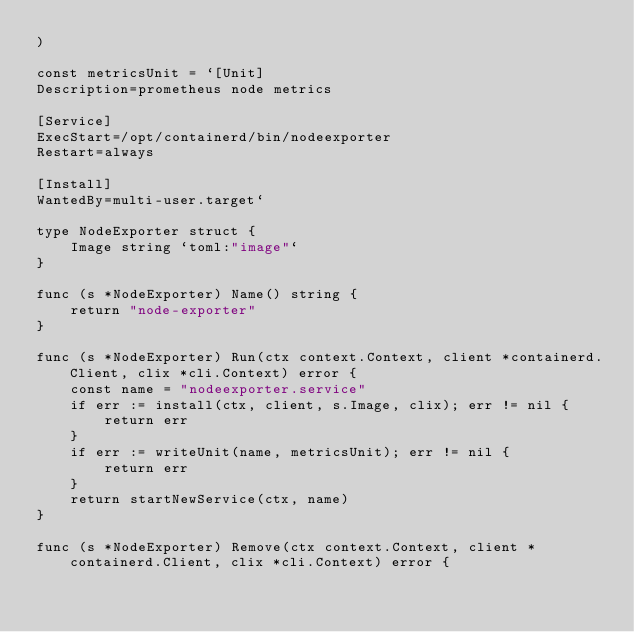Convert code to text. <code><loc_0><loc_0><loc_500><loc_500><_Go_>)

const metricsUnit = `[Unit]
Description=prometheus node metrics

[Service]
ExecStart=/opt/containerd/bin/nodeexporter
Restart=always

[Install]
WantedBy=multi-user.target`

type NodeExporter struct {
	Image string `toml:"image"`
}

func (s *NodeExporter) Name() string {
	return "node-exporter"
}

func (s *NodeExporter) Run(ctx context.Context, client *containerd.Client, clix *cli.Context) error {
	const name = "nodeexporter.service"
	if err := install(ctx, client, s.Image, clix); err != nil {
		return err
	}
	if err := writeUnit(name, metricsUnit); err != nil {
		return err
	}
	return startNewService(ctx, name)
}

func (s *NodeExporter) Remove(ctx context.Context, client *containerd.Client, clix *cli.Context) error {</code> 